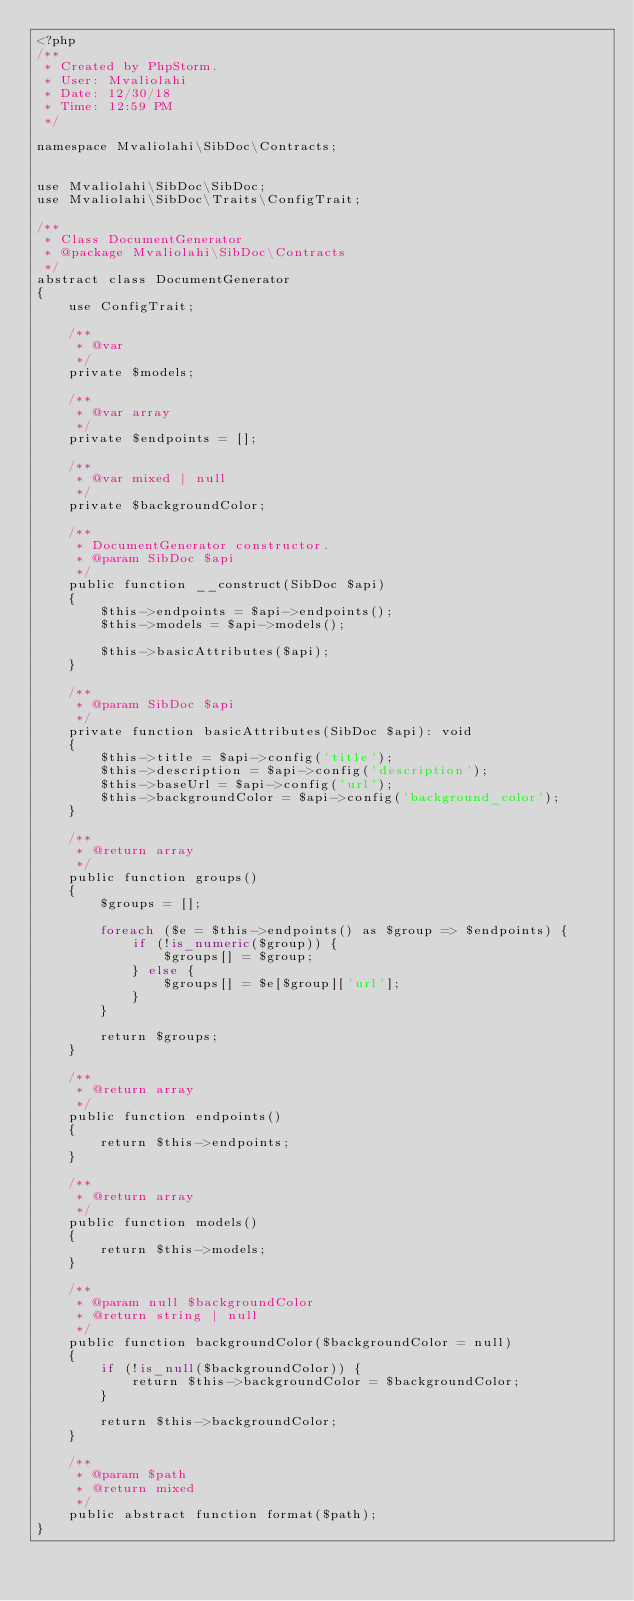Convert code to text. <code><loc_0><loc_0><loc_500><loc_500><_PHP_><?php
/**
 * Created by PhpStorm.
 * User: Mvaliolahi
 * Date: 12/30/18
 * Time: 12:59 PM
 */

namespace Mvaliolahi\SibDoc\Contracts;


use Mvaliolahi\SibDoc\SibDoc;
use Mvaliolahi\SibDoc\Traits\ConfigTrait;

/**
 * Class DocumentGenerator
 * @package Mvaliolahi\SibDoc\Contracts
 */
abstract class DocumentGenerator
{
    use ConfigTrait;

    /**
     * @var
     */
    private $models;

    /**
     * @var array
     */
    private $endpoints = [];

    /**
     * @var mixed | null
     */
    private $backgroundColor;

    /**
     * DocumentGenerator constructor.
     * @param SibDoc $api
     */
    public function __construct(SibDoc $api)
    {
        $this->endpoints = $api->endpoints();
        $this->models = $api->models();

        $this->basicAttributes($api);
    }

    /**
     * @param SibDoc $api
     */
    private function basicAttributes(SibDoc $api): void
    {
        $this->title = $api->config('title');
        $this->description = $api->config('description');
        $this->baseUrl = $api->config('url');
        $this->backgroundColor = $api->config('background_color');
    }

    /**
     * @return array
     */
    public function groups()
    {
        $groups = [];

        foreach ($e = $this->endpoints() as $group => $endpoints) {
            if (!is_numeric($group)) {
                $groups[] = $group;
            } else {
                $groups[] = $e[$group]['url'];
            }
        }

        return $groups;
    }

    /**
     * @return array
     */
    public function endpoints()
    {
        return $this->endpoints;
    }

    /**
     * @return array
     */
    public function models()
    {
        return $this->models;
    }

    /**
     * @param null $backgroundColor
     * @return string | null
     */
    public function backgroundColor($backgroundColor = null)
    {
        if (!is_null($backgroundColor)) {
            return $this->backgroundColor = $backgroundColor;
        }

        return $this->backgroundColor;
    }

    /**
     * @param $path
     * @return mixed
     */
    public abstract function format($path);
}</code> 